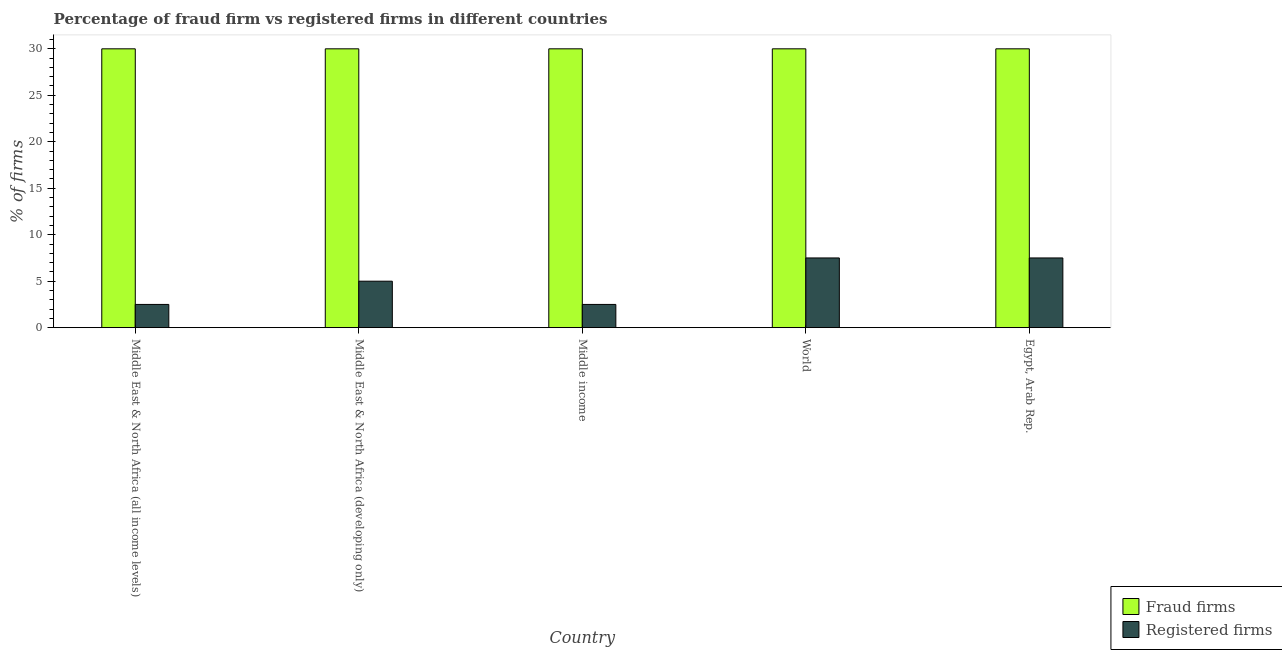How many groups of bars are there?
Your answer should be very brief. 5. How many bars are there on the 5th tick from the right?
Your answer should be very brief. 2. What is the label of the 3rd group of bars from the left?
Give a very brief answer. Middle income. What is the percentage of registered firms in Middle East & North Africa (developing only)?
Keep it short and to the point. 5. Across all countries, what is the maximum percentage of fraud firms?
Your response must be concise. 30. Across all countries, what is the minimum percentage of fraud firms?
Provide a short and direct response. 30. In which country was the percentage of fraud firms maximum?
Your response must be concise. Middle East & North Africa (all income levels). In which country was the percentage of registered firms minimum?
Your response must be concise. Middle East & North Africa (all income levels). What is the total percentage of registered firms in the graph?
Provide a short and direct response. 25. What is the difference between the percentage of registered firms in Egypt, Arab Rep. and that in Middle income?
Make the answer very short. 5. What is the difference between the percentage of registered firms and percentage of fraud firms in Middle East & North Africa (developing only)?
Offer a terse response. -25. What is the difference between the highest and the lowest percentage of fraud firms?
Ensure brevity in your answer.  0. In how many countries, is the percentage of fraud firms greater than the average percentage of fraud firms taken over all countries?
Your answer should be very brief. 0. What does the 2nd bar from the left in Middle East & North Africa (all income levels) represents?
Your response must be concise. Registered firms. What does the 1st bar from the right in Middle East & North Africa (all income levels) represents?
Make the answer very short. Registered firms. How many countries are there in the graph?
Provide a short and direct response. 5. What is the difference between two consecutive major ticks on the Y-axis?
Make the answer very short. 5. Does the graph contain grids?
Provide a short and direct response. No. Where does the legend appear in the graph?
Make the answer very short. Bottom right. How many legend labels are there?
Your response must be concise. 2. What is the title of the graph?
Ensure brevity in your answer.  Percentage of fraud firm vs registered firms in different countries. Does "Highest 20% of population" appear as one of the legend labels in the graph?
Make the answer very short. No. What is the label or title of the Y-axis?
Provide a succinct answer. % of firms. What is the % of firms in Fraud firms in Middle East & North Africa (all income levels)?
Your answer should be compact. 30. What is the % of firms of Registered firms in Middle East & North Africa (developing only)?
Provide a succinct answer. 5. What is the % of firms of Fraud firms in Middle income?
Offer a very short reply. 30. What is the % of firms of Registered firms in Middle income?
Your answer should be very brief. 2.5. What is the % of firms in Fraud firms in World?
Provide a succinct answer. 30. What is the % of firms of Fraud firms in Egypt, Arab Rep.?
Give a very brief answer. 30. Across all countries, what is the maximum % of firms of Fraud firms?
Provide a short and direct response. 30. Across all countries, what is the maximum % of firms of Registered firms?
Make the answer very short. 7.5. Across all countries, what is the minimum % of firms in Fraud firms?
Your answer should be compact. 30. Across all countries, what is the minimum % of firms of Registered firms?
Give a very brief answer. 2.5. What is the total % of firms of Fraud firms in the graph?
Your answer should be compact. 150. What is the total % of firms of Registered firms in the graph?
Make the answer very short. 25. What is the difference between the % of firms in Fraud firms in Middle East & North Africa (all income levels) and that in Middle East & North Africa (developing only)?
Your response must be concise. 0. What is the difference between the % of firms of Registered firms in Middle East & North Africa (all income levels) and that in Middle East & North Africa (developing only)?
Provide a short and direct response. -2.5. What is the difference between the % of firms in Fraud firms in Middle East & North Africa (all income levels) and that in World?
Your answer should be compact. 0. What is the difference between the % of firms of Registered firms in Middle East & North Africa (all income levels) and that in World?
Keep it short and to the point. -5. What is the difference between the % of firms in Fraud firms in Middle East & North Africa (developing only) and that in World?
Give a very brief answer. 0. What is the difference between the % of firms in Registered firms in Middle East & North Africa (developing only) and that in World?
Make the answer very short. -2.5. What is the difference between the % of firms of Registered firms in World and that in Egypt, Arab Rep.?
Your answer should be compact. 0. What is the difference between the % of firms of Fraud firms in Middle East & North Africa (all income levels) and the % of firms of Registered firms in Middle income?
Offer a terse response. 27.5. What is the difference between the % of firms in Fraud firms in Middle East & North Africa (all income levels) and the % of firms in Registered firms in Egypt, Arab Rep.?
Your response must be concise. 22.5. What is the difference between the % of firms of Fraud firms in Middle East & North Africa (developing only) and the % of firms of Registered firms in World?
Give a very brief answer. 22.5. What is the difference between the % of firms in Fraud firms in Middle East & North Africa (developing only) and the % of firms in Registered firms in Egypt, Arab Rep.?
Offer a very short reply. 22.5. What is the difference between the % of firms of Fraud firms in World and the % of firms of Registered firms in Egypt, Arab Rep.?
Provide a short and direct response. 22.5. What is the average % of firms in Fraud firms per country?
Offer a very short reply. 30. What is the average % of firms of Registered firms per country?
Offer a terse response. 5. What is the difference between the % of firms in Fraud firms and % of firms in Registered firms in Middle East & North Africa (all income levels)?
Give a very brief answer. 27.5. What is the difference between the % of firms of Fraud firms and % of firms of Registered firms in Middle East & North Africa (developing only)?
Your answer should be very brief. 25. What is the difference between the % of firms of Fraud firms and % of firms of Registered firms in Middle income?
Your answer should be very brief. 27.5. What is the difference between the % of firms of Fraud firms and % of firms of Registered firms in World?
Offer a very short reply. 22.5. What is the difference between the % of firms in Fraud firms and % of firms in Registered firms in Egypt, Arab Rep.?
Your answer should be compact. 22.5. What is the ratio of the % of firms in Fraud firms in Middle East & North Africa (all income levels) to that in Middle East & North Africa (developing only)?
Offer a terse response. 1. What is the ratio of the % of firms of Registered firms in Middle East & North Africa (all income levels) to that in Middle East & North Africa (developing only)?
Offer a terse response. 0.5. What is the ratio of the % of firms of Fraud firms in Middle East & North Africa (all income levels) to that in Middle income?
Keep it short and to the point. 1. What is the ratio of the % of firms in Registered firms in Middle East & North Africa (all income levels) to that in Middle income?
Make the answer very short. 1. What is the ratio of the % of firms of Fraud firms in Middle East & North Africa (all income levels) to that in Egypt, Arab Rep.?
Provide a succinct answer. 1. What is the ratio of the % of firms of Registered firms in Middle East & North Africa (all income levels) to that in Egypt, Arab Rep.?
Give a very brief answer. 0.33. What is the ratio of the % of firms in Registered firms in Middle East & North Africa (developing only) to that in Middle income?
Keep it short and to the point. 2. What is the ratio of the % of firms in Registered firms in Middle East & North Africa (developing only) to that in Egypt, Arab Rep.?
Provide a short and direct response. 0.67. What is the ratio of the % of firms in Fraud firms in Middle income to that in World?
Offer a terse response. 1. What is the ratio of the % of firms in Registered firms in Middle income to that in World?
Your answer should be very brief. 0.33. What is the ratio of the % of firms in Fraud firms in Middle income to that in Egypt, Arab Rep.?
Provide a short and direct response. 1. What is the ratio of the % of firms of Fraud firms in World to that in Egypt, Arab Rep.?
Provide a succinct answer. 1. What is the ratio of the % of firms of Registered firms in World to that in Egypt, Arab Rep.?
Keep it short and to the point. 1. What is the difference between the highest and the lowest % of firms of Fraud firms?
Your answer should be very brief. 0. 